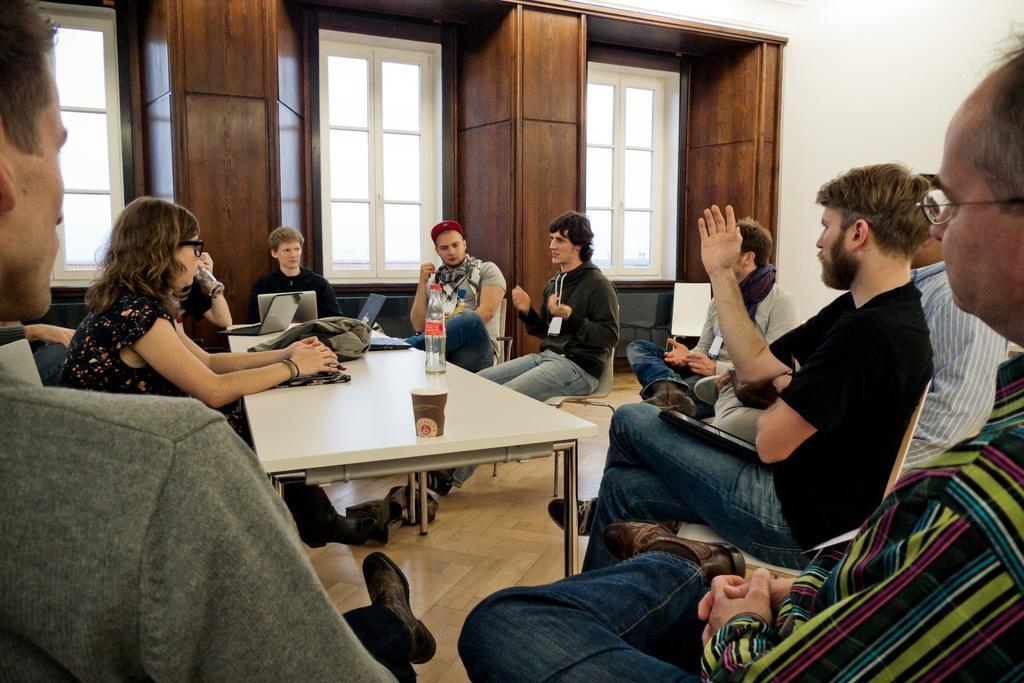Please provide a concise description of this image. In this picture we can see group of persons sitting on chairs and in front of them there is table and on table we can see bottle, glass, jacket and in background we can see windows, wall. 